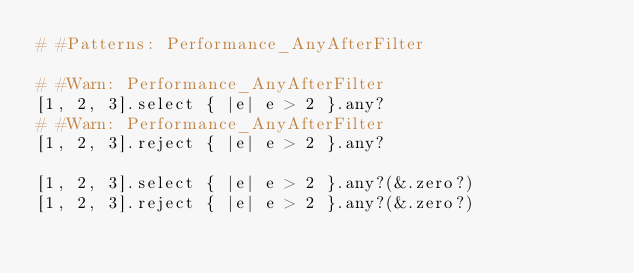<code> <loc_0><loc_0><loc_500><loc_500><_Crystal_># #Patterns: Performance_AnyAfterFilter

# #Warn: Performance_AnyAfterFilter
[1, 2, 3].select { |e| e > 2 }.any?
# #Warn: Performance_AnyAfterFilter
[1, 2, 3].reject { |e| e > 2 }.any?

[1, 2, 3].select { |e| e > 2 }.any?(&.zero?)
[1, 2, 3].reject { |e| e > 2 }.any?(&.zero?)
</code> 